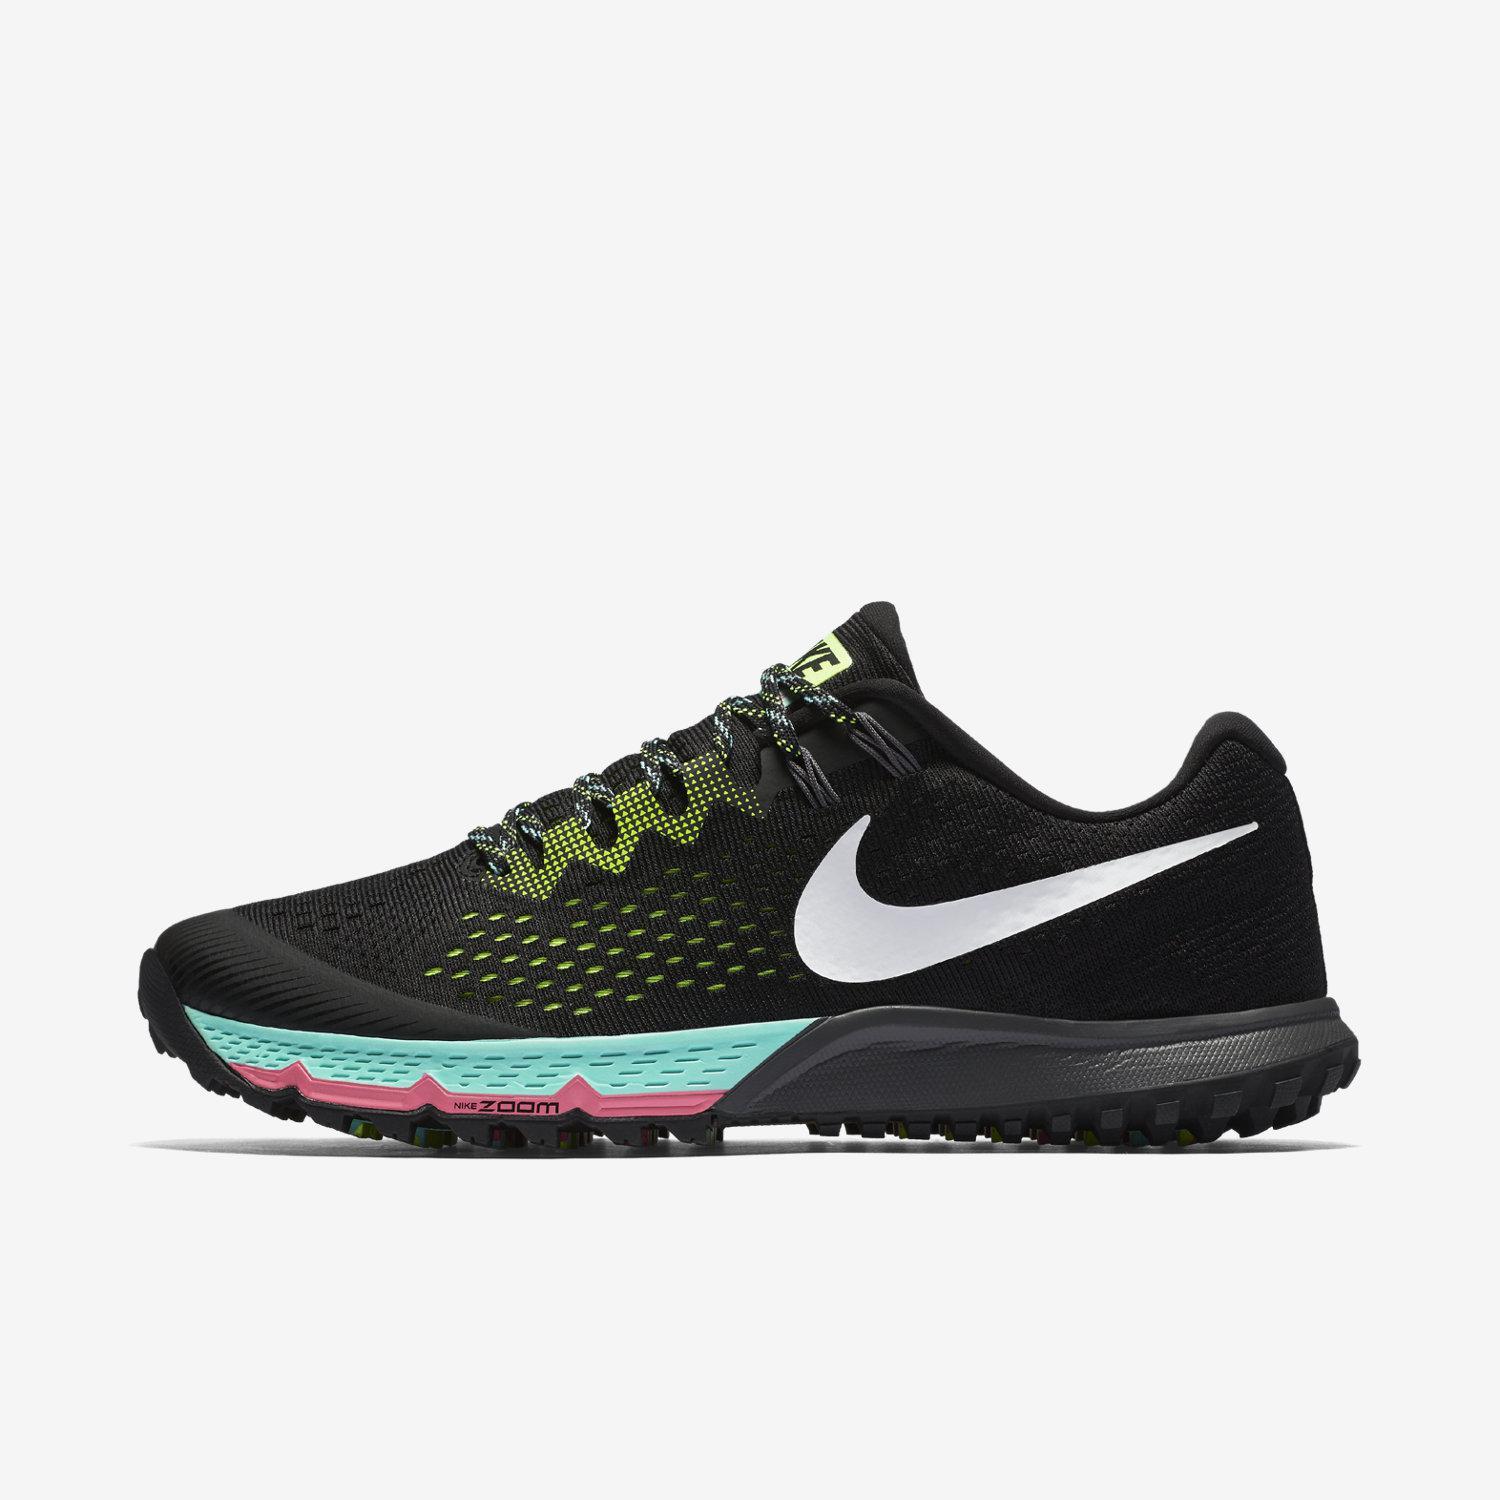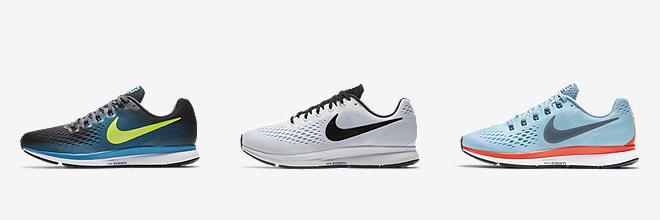The first image is the image on the left, the second image is the image on the right. Analyze the images presented: Is the assertion "Three shoe color options are shown in one image." valid? Answer yes or no. Yes. 